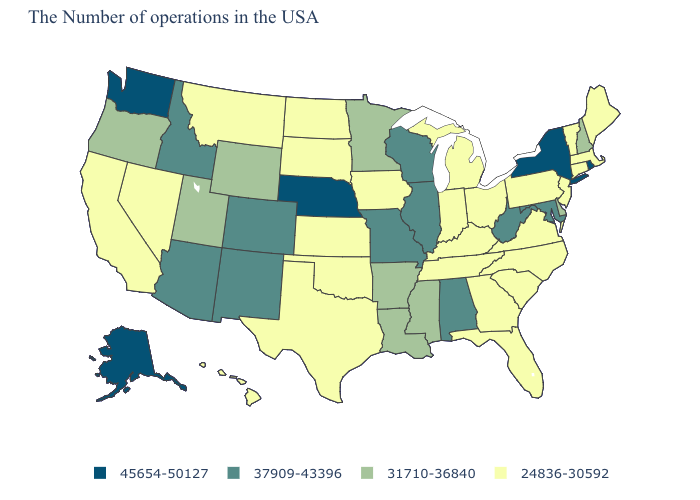What is the value of Wyoming?
Quick response, please. 31710-36840. Name the states that have a value in the range 24836-30592?
Write a very short answer. Maine, Massachusetts, Vermont, Connecticut, New Jersey, Pennsylvania, Virginia, North Carolina, South Carolina, Ohio, Florida, Georgia, Michigan, Kentucky, Indiana, Tennessee, Iowa, Kansas, Oklahoma, Texas, South Dakota, North Dakota, Montana, Nevada, California, Hawaii. Does Rhode Island have the highest value in the USA?
Short answer required. Yes. Name the states that have a value in the range 31710-36840?
Answer briefly. New Hampshire, Delaware, Mississippi, Louisiana, Arkansas, Minnesota, Wyoming, Utah, Oregon. Does Pennsylvania have the highest value in the Northeast?
Write a very short answer. No. Among the states that border Mississippi , does Alabama have the highest value?
Write a very short answer. Yes. Name the states that have a value in the range 24836-30592?
Give a very brief answer. Maine, Massachusetts, Vermont, Connecticut, New Jersey, Pennsylvania, Virginia, North Carolina, South Carolina, Ohio, Florida, Georgia, Michigan, Kentucky, Indiana, Tennessee, Iowa, Kansas, Oklahoma, Texas, South Dakota, North Dakota, Montana, Nevada, California, Hawaii. Does Idaho have a higher value than Louisiana?
Be succinct. Yes. What is the value of Nebraska?
Give a very brief answer. 45654-50127. Does Nebraska have the highest value in the USA?
Keep it brief. Yes. Name the states that have a value in the range 37909-43396?
Give a very brief answer. Maryland, West Virginia, Alabama, Wisconsin, Illinois, Missouri, Colorado, New Mexico, Arizona, Idaho. Name the states that have a value in the range 24836-30592?
Quick response, please. Maine, Massachusetts, Vermont, Connecticut, New Jersey, Pennsylvania, Virginia, North Carolina, South Carolina, Ohio, Florida, Georgia, Michigan, Kentucky, Indiana, Tennessee, Iowa, Kansas, Oklahoma, Texas, South Dakota, North Dakota, Montana, Nevada, California, Hawaii. Which states have the lowest value in the West?
Write a very short answer. Montana, Nevada, California, Hawaii. Is the legend a continuous bar?
Quick response, please. No. Name the states that have a value in the range 24836-30592?
Concise answer only. Maine, Massachusetts, Vermont, Connecticut, New Jersey, Pennsylvania, Virginia, North Carolina, South Carolina, Ohio, Florida, Georgia, Michigan, Kentucky, Indiana, Tennessee, Iowa, Kansas, Oklahoma, Texas, South Dakota, North Dakota, Montana, Nevada, California, Hawaii. 